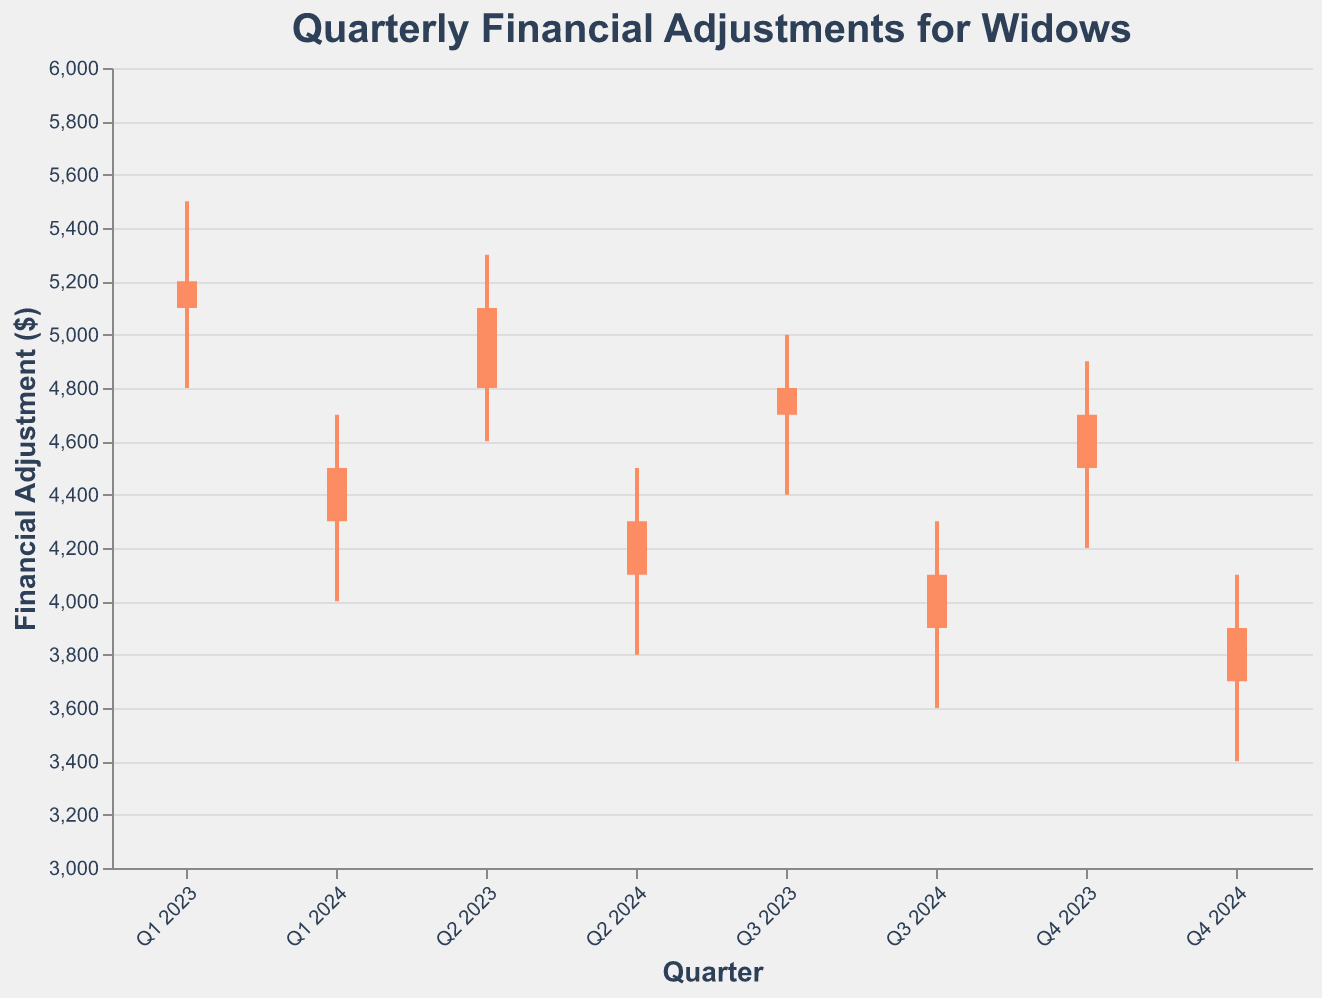What is the title of the chart? The title of the chart is indicated at the top of the figure. It reads "Quarterly Financial Adjustments for Widows".
Answer: Quarterly Financial Adjustments for Widows How does the color of the bars change in the chart? The color of the bars changes based on whether the financial adjustment increased or decreased over the quarter. If the open value is less than the close value, the bar is green, indicating a positive financial adjustment. If the open value is greater than the close value, the bar is red, indicating a negative financial adjustment.
Answer: Red for negative, Green for positive Which quarter saw the highest financial adjustment close value? By comparing the close values of each quarter, Q1 2023 has the highest close value of 5100.
Answer: Q1 2023 Between which quarters did the financial adjustment experience the greatest decrease? To find the greatest decrease, calculate the difference between the open and close values for each quarter. Q4 2023 to Q1 2024 saw the financial adjustment decreasing from 4500 to 4300, which is a decrease of 200. However, Q1 2023 to Q2 2023 saw a decrease from 5100 to 4800, which is a 300 decrease. Comparing all quarters, Q1 2023 to Q2 2023 saw the greatest decrease of 300.
Answer: Q1 2023 to Q2 2023 What is the trend of the financial adjustments from Q1 2023 to Q4 2024? Observing the trend of the close values across the quarters, there is a steady decline in the financial adjustments from 5100 in Q1 2023 to 3700 in Q4 2024.
Answer: Declining Which quarter had the lowest high value? By observing the high values of each quarter, Q4 2024 had the lowest high value of 4100.
Answer: Q4 2024 What is the range of financial adjustments for Q3 2024? The range can be found by subtracting the low value from the high value. For Q3 2024, the high is 4300, and the low is 3600. Therefore, the range is 4300 - 360 = 700.
Answer: 700 During which quarter was the financial adjustment low value the highest? Comparing the low values across all quarters, the highest low value is 4800 in Q1 2023.
Answer: Q1 2023 Which quarter had the smallest difference between its high and low values? To find this, calculate the difference between the high and low values for each quarter. The smallest difference is from Q2 2023, with a difference of 5300 - 4600 = 700.
Answer: Q2 2023 